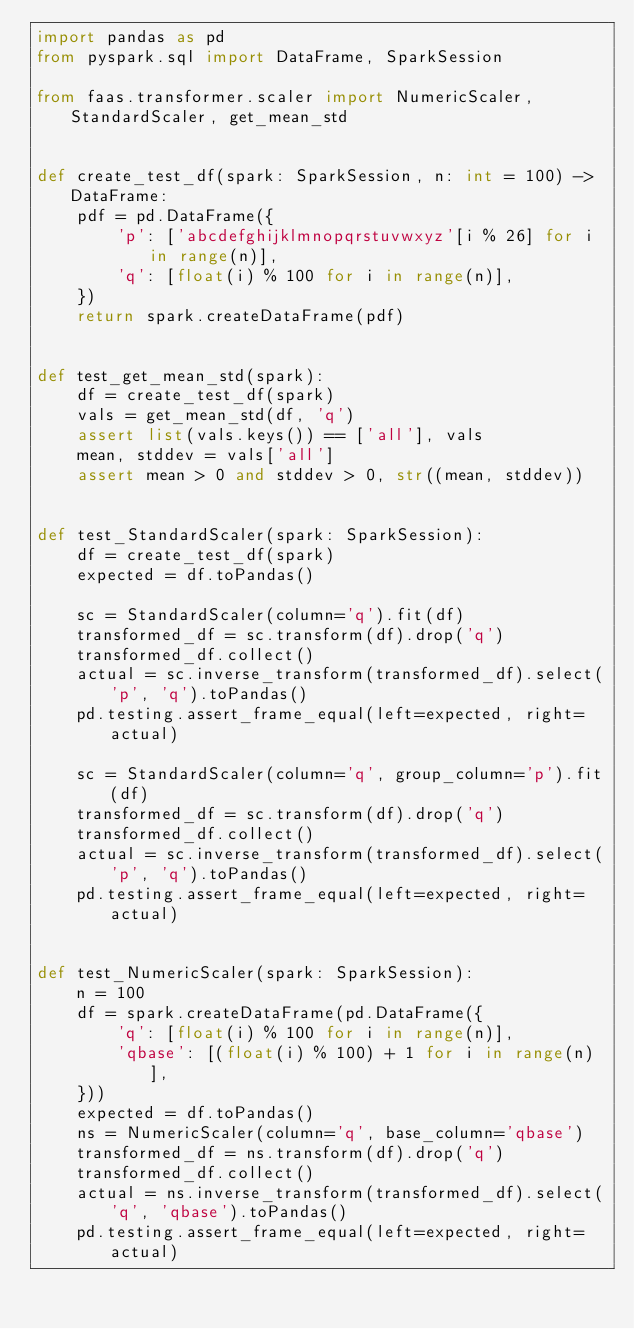<code> <loc_0><loc_0><loc_500><loc_500><_Python_>import pandas as pd
from pyspark.sql import DataFrame, SparkSession

from faas.transformer.scaler import NumericScaler, StandardScaler, get_mean_std


def create_test_df(spark: SparkSession, n: int = 100) -> DataFrame:
    pdf = pd.DataFrame({
        'p': ['abcdefghijklmnopqrstuvwxyz'[i % 26] for i in range(n)],
        'q': [float(i) % 100 for i in range(n)],
    })
    return spark.createDataFrame(pdf)


def test_get_mean_std(spark):
    df = create_test_df(spark)
    vals = get_mean_std(df, 'q')
    assert list(vals.keys()) == ['all'], vals
    mean, stddev = vals['all']
    assert mean > 0 and stddev > 0, str((mean, stddev))


def test_StandardScaler(spark: SparkSession):
    df = create_test_df(spark)
    expected = df.toPandas()

    sc = StandardScaler(column='q').fit(df)
    transformed_df = sc.transform(df).drop('q')
    transformed_df.collect()
    actual = sc.inverse_transform(transformed_df).select('p', 'q').toPandas()
    pd.testing.assert_frame_equal(left=expected, right=actual)

    sc = StandardScaler(column='q', group_column='p').fit(df)
    transformed_df = sc.transform(df).drop('q')
    transformed_df.collect()
    actual = sc.inverse_transform(transformed_df).select('p', 'q').toPandas()
    pd.testing.assert_frame_equal(left=expected, right=actual)


def test_NumericScaler(spark: SparkSession):
    n = 100
    df = spark.createDataFrame(pd.DataFrame({
        'q': [float(i) % 100 for i in range(n)],
        'qbase': [(float(i) % 100) + 1 for i in range(n)],
    }))
    expected = df.toPandas()
    ns = NumericScaler(column='q', base_column='qbase')
    transformed_df = ns.transform(df).drop('q')
    transformed_df.collect()
    actual = ns.inverse_transform(transformed_df).select('q', 'qbase').toPandas()
    pd.testing.assert_frame_equal(left=expected, right=actual)
</code> 